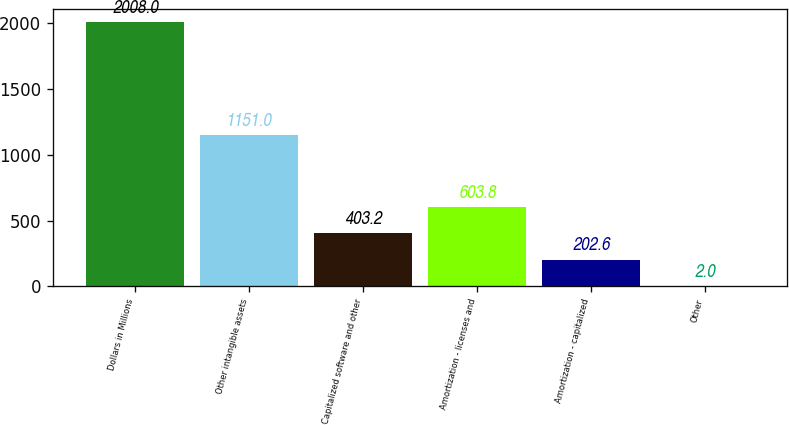Convert chart. <chart><loc_0><loc_0><loc_500><loc_500><bar_chart><fcel>Dollars in Millions<fcel>Other intangible assets<fcel>Capitalized software and other<fcel>Amortization - licenses and<fcel>Amortization - capitalized<fcel>Other<nl><fcel>2008<fcel>1151<fcel>403.2<fcel>603.8<fcel>202.6<fcel>2<nl></chart> 